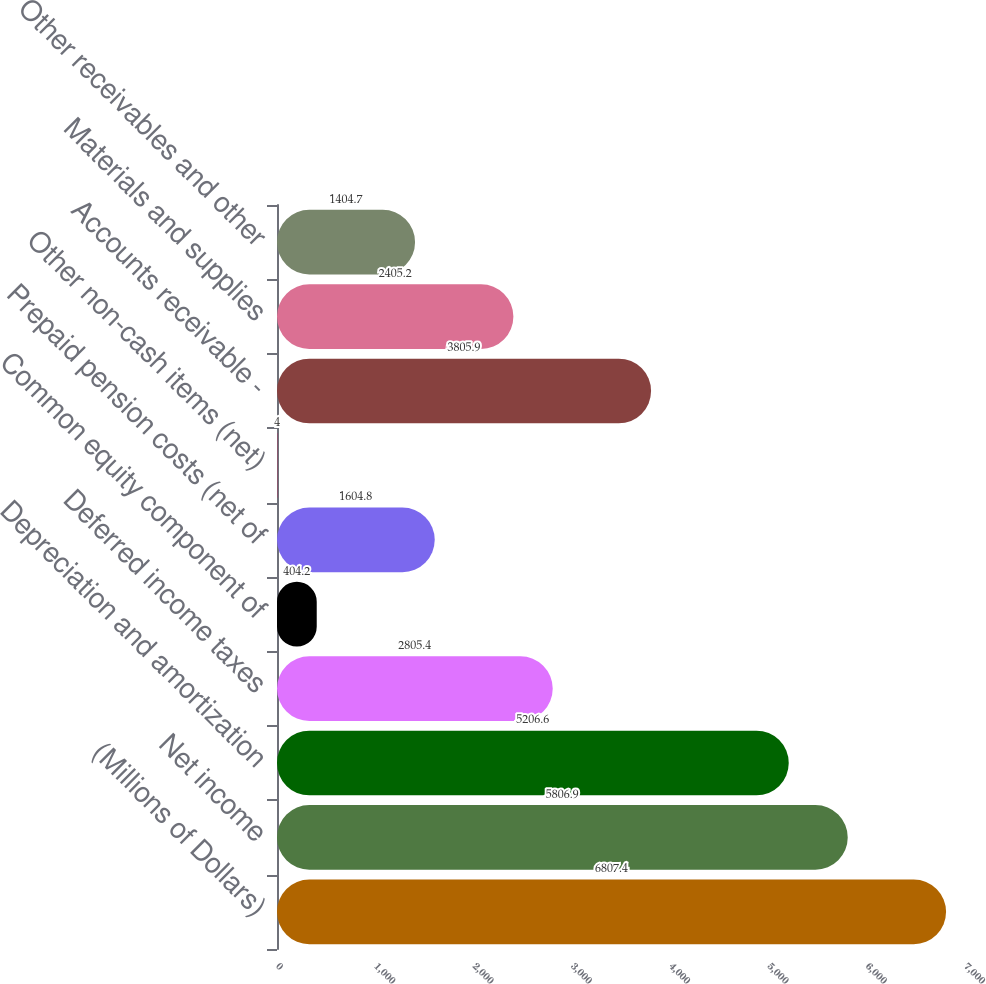Convert chart. <chart><loc_0><loc_0><loc_500><loc_500><bar_chart><fcel>(Millions of Dollars)<fcel>Net income<fcel>Depreciation and amortization<fcel>Deferred income taxes<fcel>Common equity component of<fcel>Prepaid pension costs (net of<fcel>Other non-cash items (net)<fcel>Accounts receivable -<fcel>Materials and supplies<fcel>Other receivables and other<nl><fcel>6807.4<fcel>5806.9<fcel>5206.6<fcel>2805.4<fcel>404.2<fcel>1604.8<fcel>4<fcel>3805.9<fcel>2405.2<fcel>1404.7<nl></chart> 